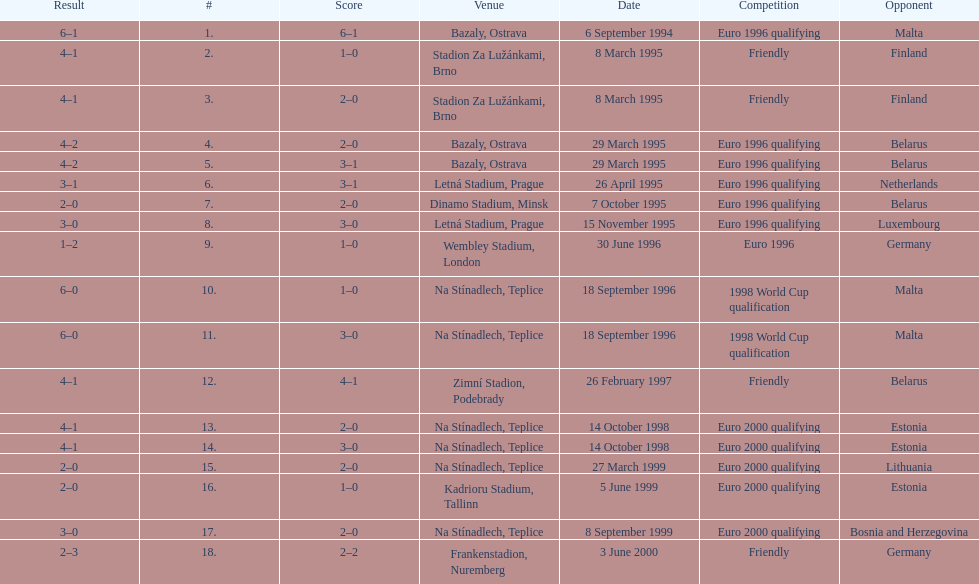What venue is listed above wembley stadium, london? Letná Stadium, Prague. 